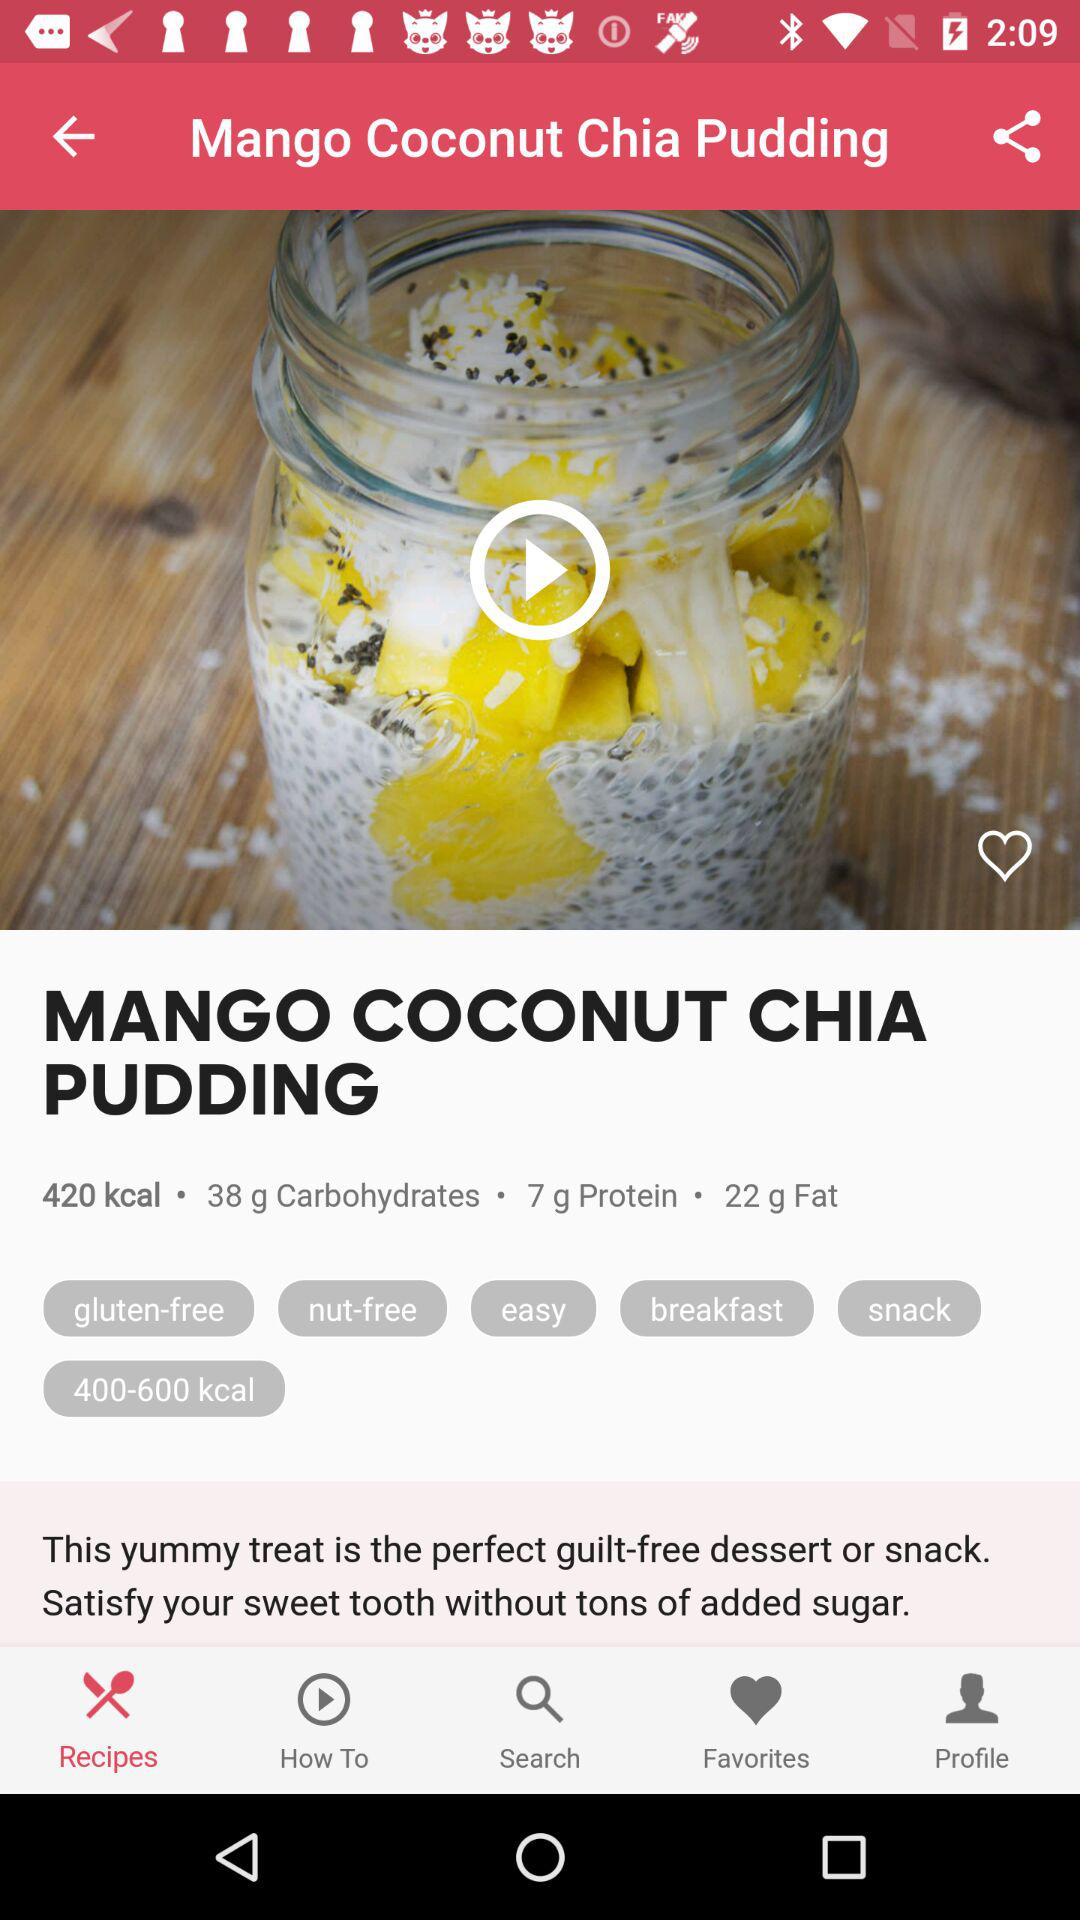Is this dish suitable for someone with dietary restrictions? Absolutely! The Mango Coconut Chia Pudding is labeled as gluten-free and nut-free, making it a great choice for individuals with those specific dietary needs. It also provides a balance of macronutrients and is described as easy to prepare. 